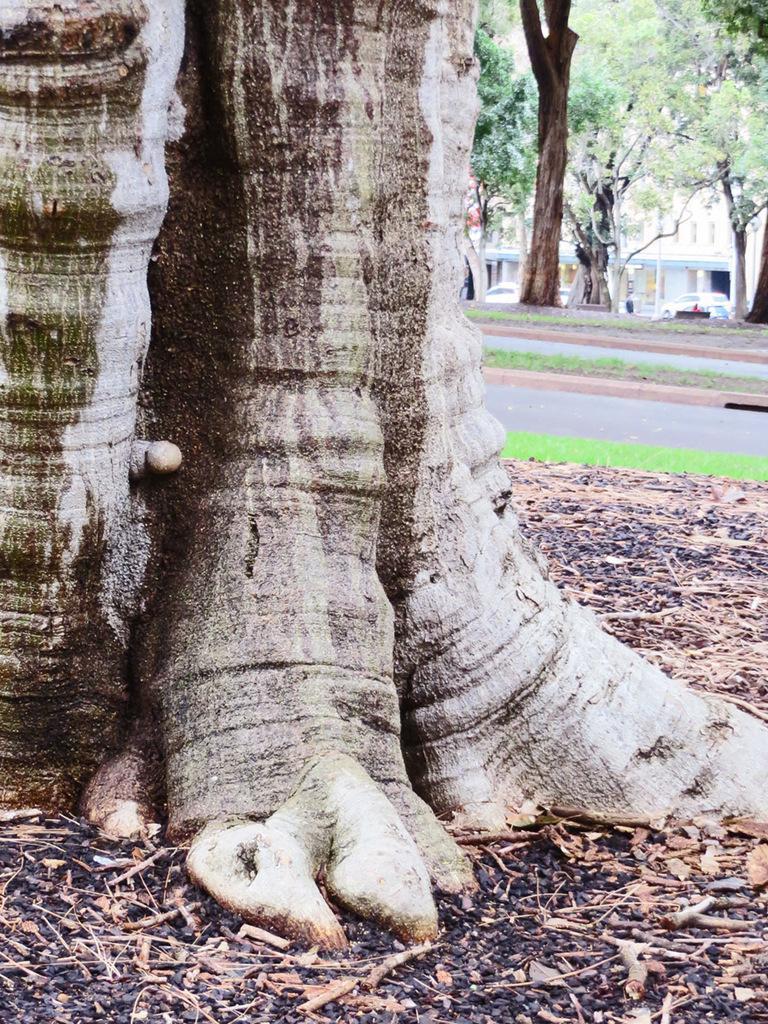How would you summarize this image in a sentence or two? In this image we can see trees and there is a road. We can see cars on the road. At the bottom there is grass and we can see twigs. 